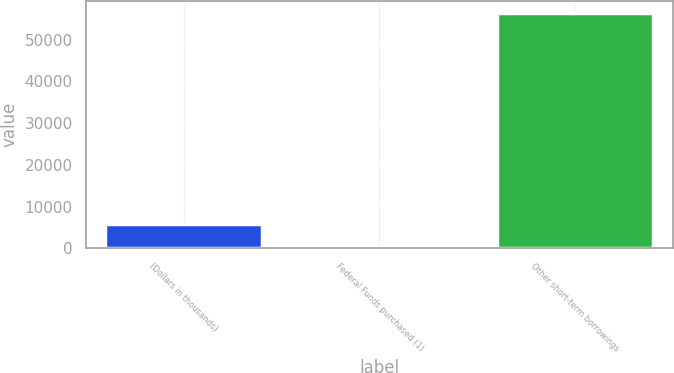Convert chart to OTSL. <chart><loc_0><loc_0><loc_500><loc_500><bar_chart><fcel>(Dollars in thousands)<fcel>Federal Funds purchased (1)<fcel>Other short-term borrowings<nl><fcel>5952.8<fcel>342<fcel>56450<nl></chart> 